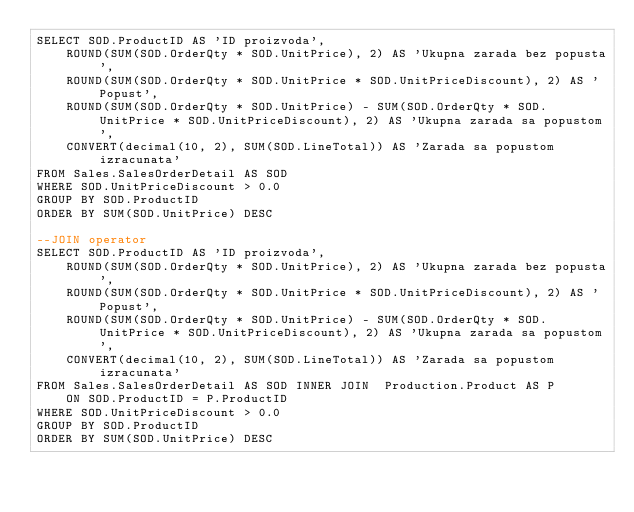<code> <loc_0><loc_0><loc_500><loc_500><_SQL_>SELECT SOD.ProductID AS 'ID proizvoda',
	ROUND(SUM(SOD.OrderQty * SOD.UnitPrice), 2) AS 'Ukupna zarada bez popusta',
	ROUND(SUM(SOD.OrderQty * SOD.UnitPrice * SOD.UnitPriceDiscount), 2) AS 'Popust',
	ROUND(SUM(SOD.OrderQty * SOD.UnitPrice) - SUM(SOD.OrderQty * SOD.UnitPrice * SOD.UnitPriceDiscount), 2) AS 'Ukupna zarada sa popustom',
	CONVERT(decimal(10, 2), SUM(SOD.LineTotal)) AS 'Zarada sa popustom izracunata'
FROM Sales.SalesOrderDetail AS SOD
WHERE SOD.UnitPriceDiscount > 0.0
GROUP BY SOD.ProductID
ORDER BY SUM(SOD.UnitPrice) DESC

--JOIN operator
SELECT SOD.ProductID AS 'ID proizvoda',
	ROUND(SUM(SOD.OrderQty * SOD.UnitPrice), 2) AS 'Ukupna zarada bez popusta',
	ROUND(SUM(SOD.OrderQty * SOD.UnitPrice * SOD.UnitPriceDiscount), 2) AS 'Popust',
	ROUND(SUM(SOD.OrderQty * SOD.UnitPrice) - SUM(SOD.OrderQty * SOD.UnitPrice * SOD.UnitPriceDiscount), 2) AS 'Ukupna zarada sa popustom',
	CONVERT(decimal(10, 2), SUM(SOD.LineTotal)) AS 'Zarada sa popustom izracunata'
FROM Sales.SalesOrderDetail AS SOD INNER JOIN  Production.Product AS P
	ON SOD.ProductID = P.ProductID
WHERE SOD.UnitPriceDiscount > 0.0
GROUP BY SOD.ProductID
ORDER BY SUM(SOD.UnitPrice) DESC</code> 